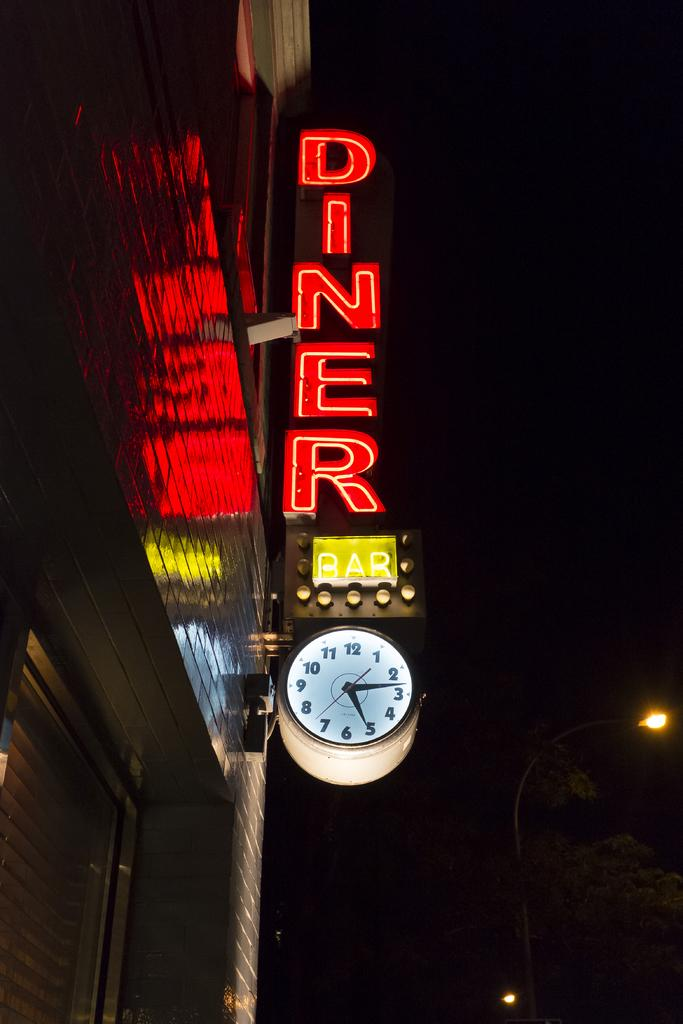Provide a one-sentence caption for the provided image. A diner sign lit up by neon on a post. 